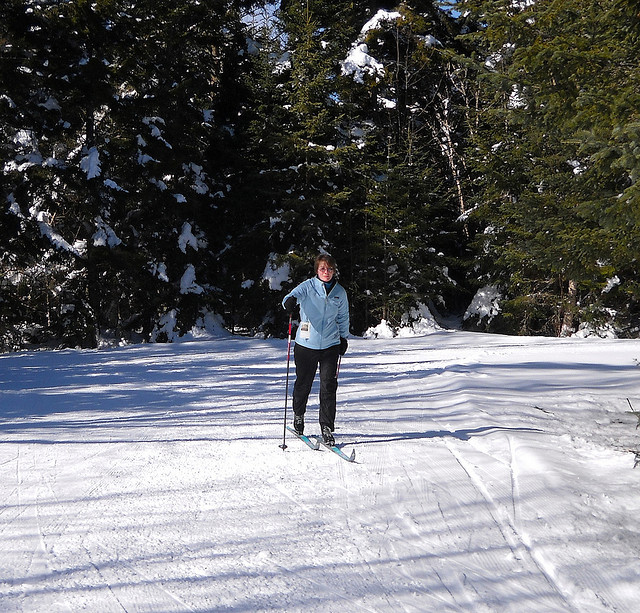How many dogs are standing in boat? 0 